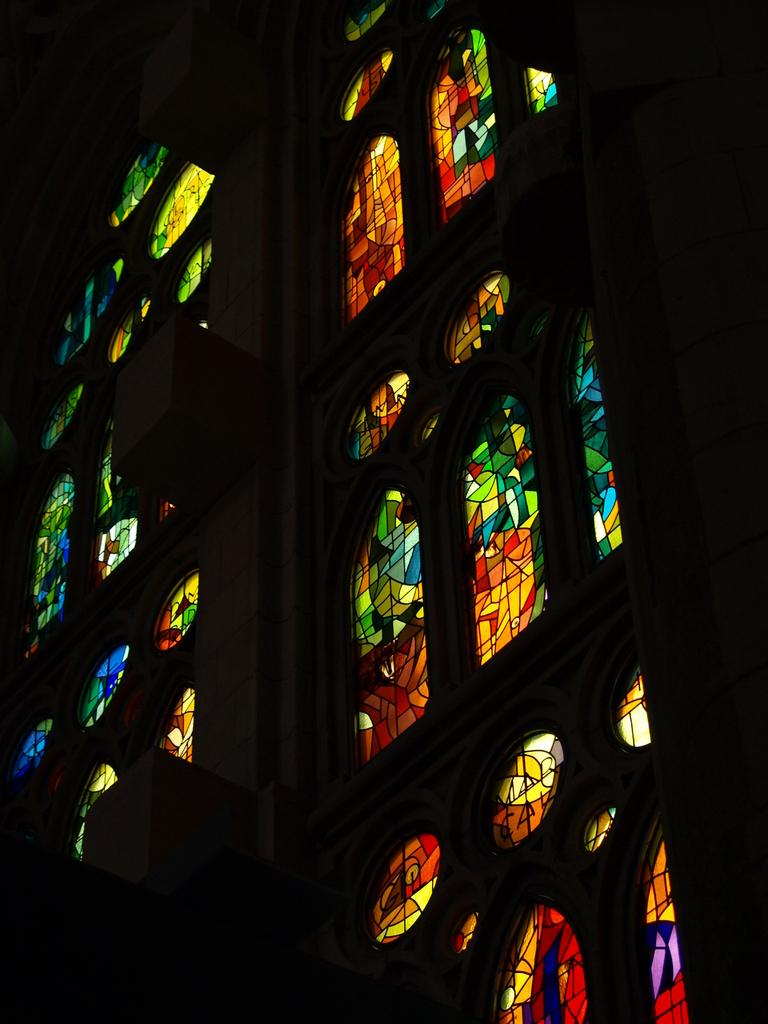What type of structure is visible in the image? There is a building in the image. Can you describe a specific feature of the building? There is a window with lights in the image. What is the color of the top and bottom of the image? The top and bottom of the image appear to be black. What type of vegetable can be seen growing in the image? There are no vegetables present in the image. 